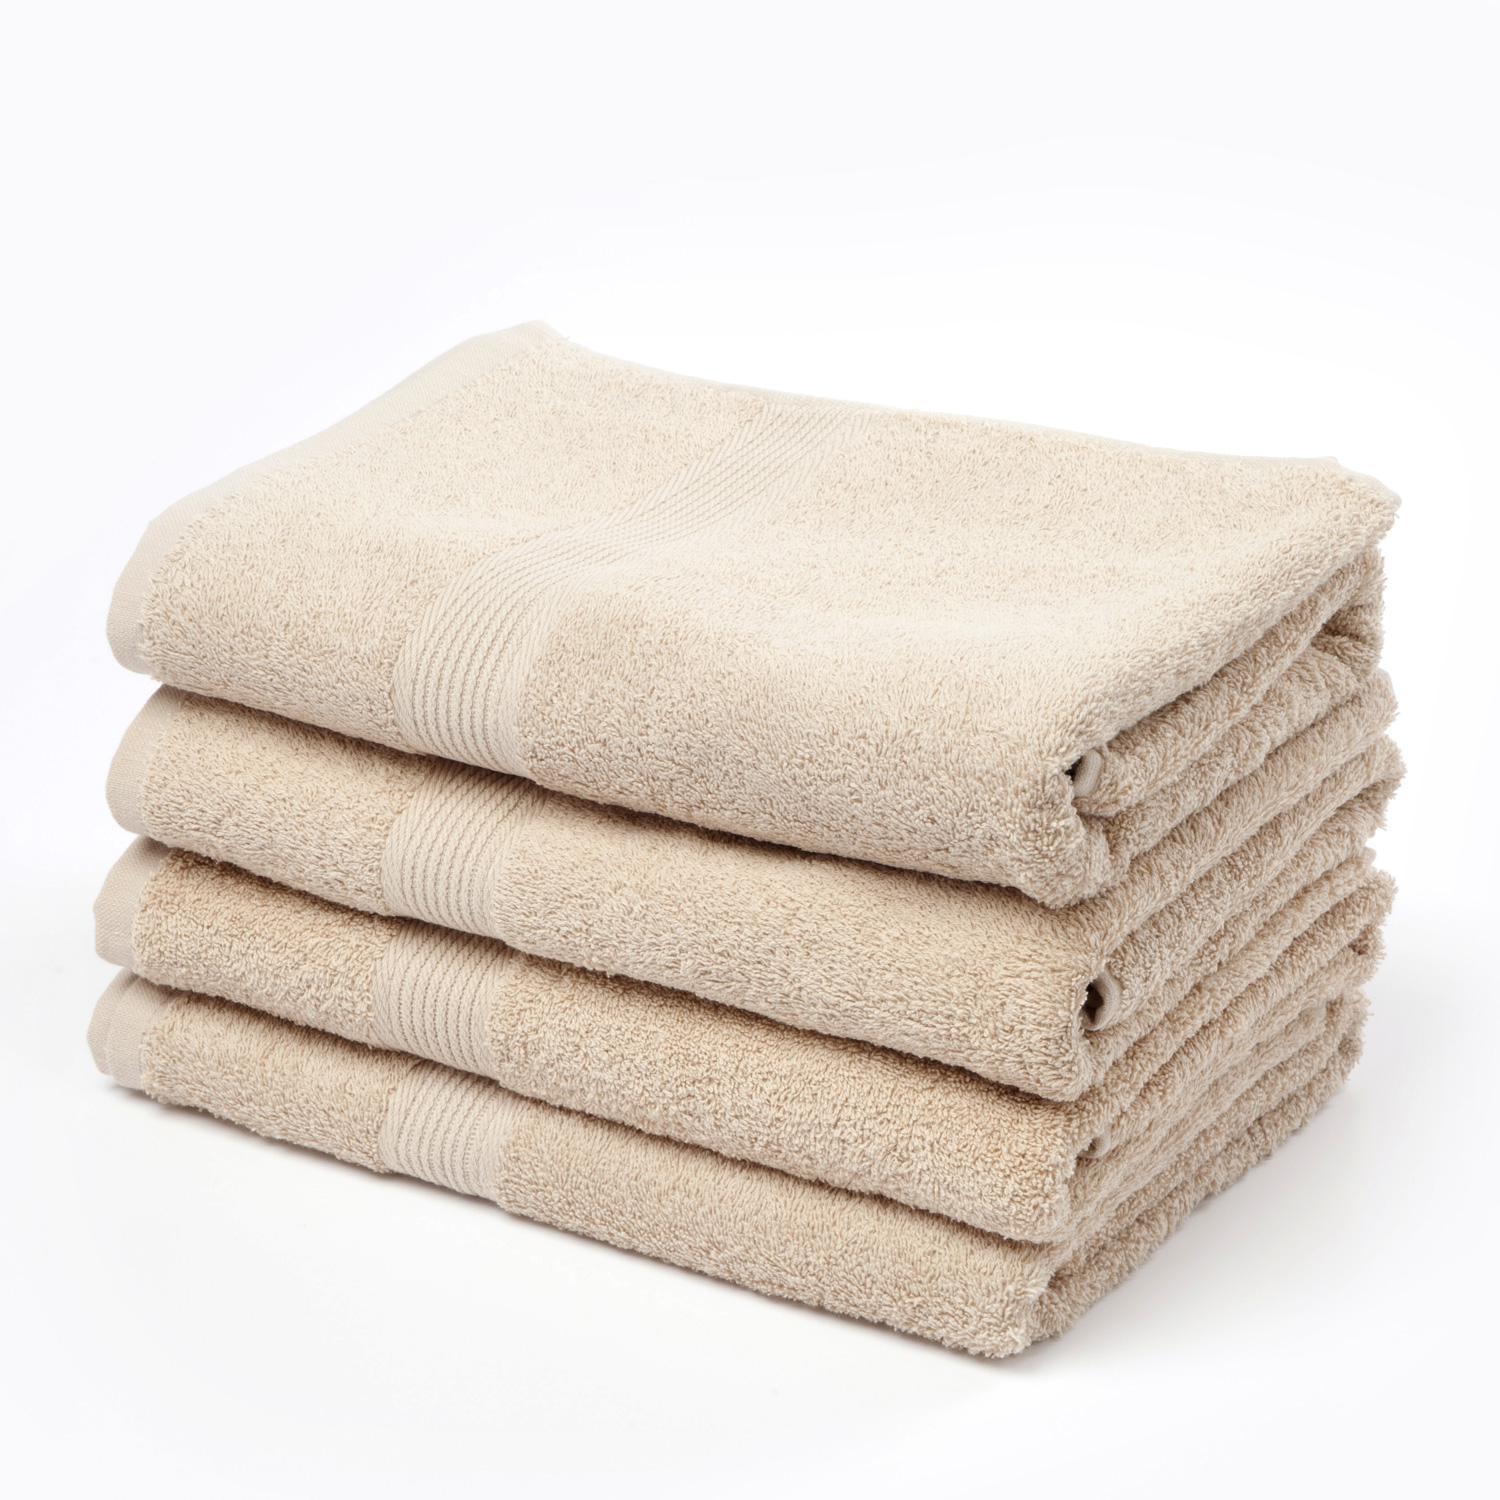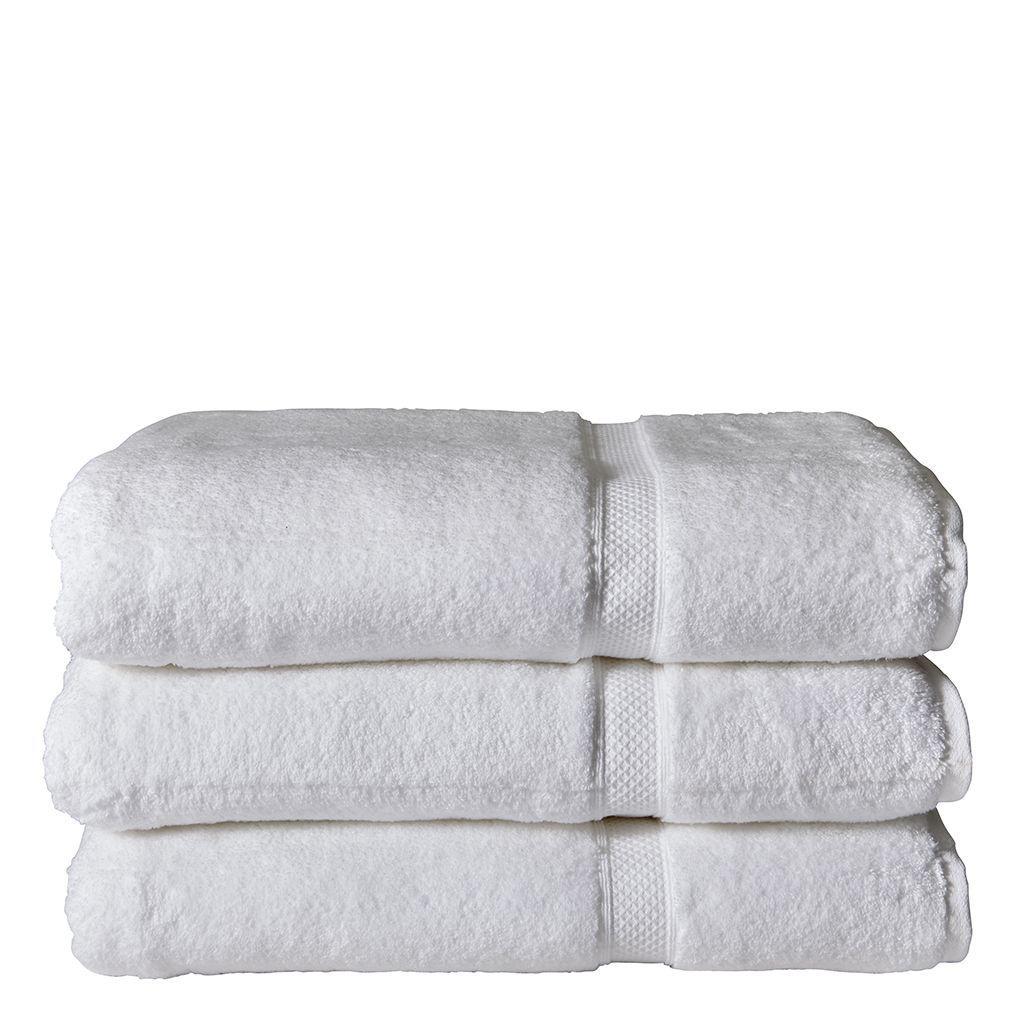The first image is the image on the left, the second image is the image on the right. Given the left and right images, does the statement "Fabric color is obviously grey." hold true? Answer yes or no. No. 